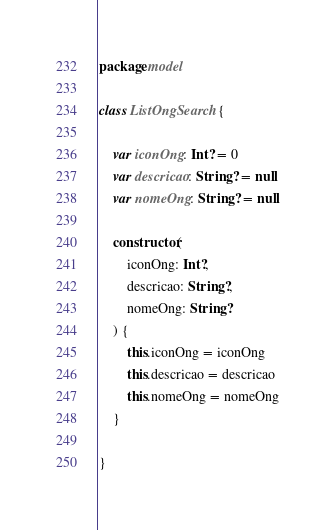Convert code to text. <code><loc_0><loc_0><loc_500><loc_500><_Kotlin_>package model

class ListOngSearch {

    var iconOng: Int? = 0
    var descricao: String? = null
    var nomeOng: String? = null

    constructor(
        iconOng: Int?,
        descricao: String?,
        nomeOng: String?
    ) {
        this.iconOng = iconOng
        this.descricao = descricao
        this.nomeOng = nomeOng
    }

}</code> 